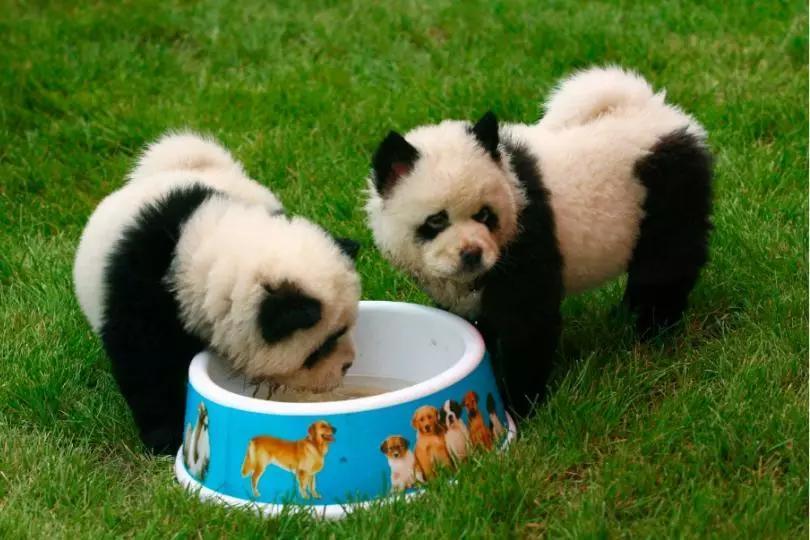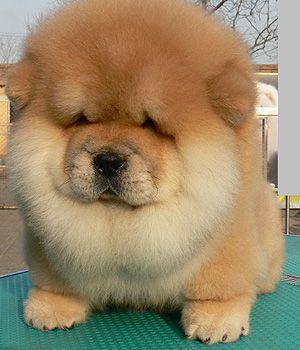The first image is the image on the left, the second image is the image on the right. For the images shown, is this caption "One image contains exactly two look-alike chow pups on green grass." true? Answer yes or no. Yes. The first image is the image on the left, the second image is the image on the right. Given the left and right images, does the statement "There are two Chow Chows." hold true? Answer yes or no. No. 